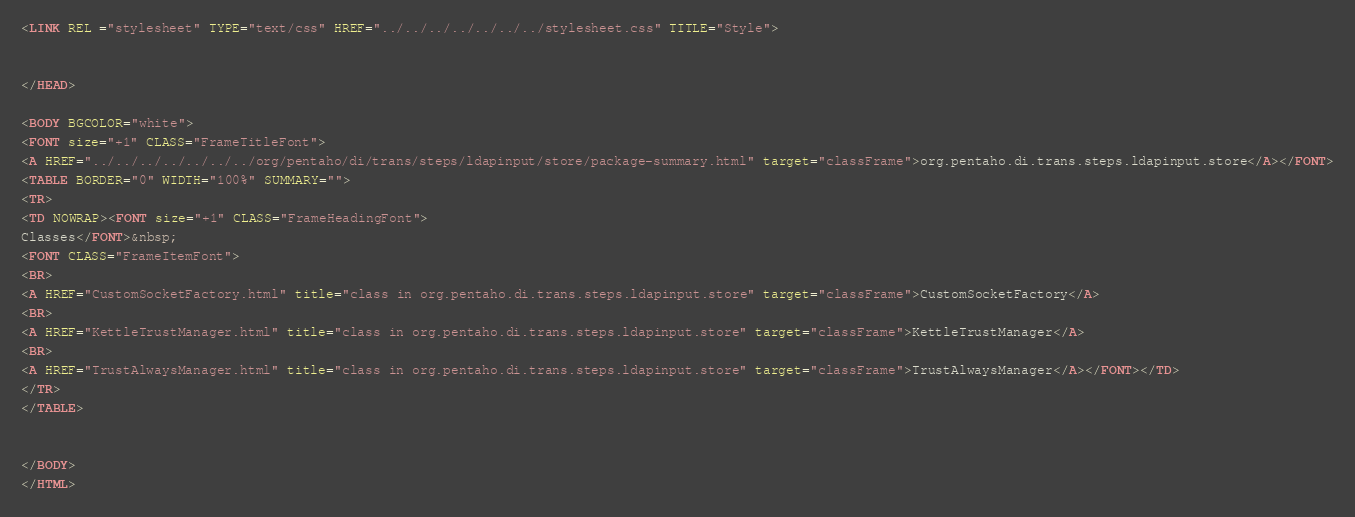Convert code to text. <code><loc_0><loc_0><loc_500><loc_500><_HTML_><LINK REL ="stylesheet" TYPE="text/css" HREF="../../../../../../../stylesheet.css" TITLE="Style">


</HEAD>

<BODY BGCOLOR="white">
<FONT size="+1" CLASS="FrameTitleFont">
<A HREF="../../../../../../../org/pentaho/di/trans/steps/ldapinput/store/package-summary.html" target="classFrame">org.pentaho.di.trans.steps.ldapinput.store</A></FONT>
<TABLE BORDER="0" WIDTH="100%" SUMMARY="">
<TR>
<TD NOWRAP><FONT size="+1" CLASS="FrameHeadingFont">
Classes</FONT>&nbsp;
<FONT CLASS="FrameItemFont">
<BR>
<A HREF="CustomSocketFactory.html" title="class in org.pentaho.di.trans.steps.ldapinput.store" target="classFrame">CustomSocketFactory</A>
<BR>
<A HREF="KettleTrustManager.html" title="class in org.pentaho.di.trans.steps.ldapinput.store" target="classFrame">KettleTrustManager</A>
<BR>
<A HREF="TrustAlwaysManager.html" title="class in org.pentaho.di.trans.steps.ldapinput.store" target="classFrame">TrustAlwaysManager</A></FONT></TD>
</TR>
</TABLE>


</BODY>
</HTML>
</code> 